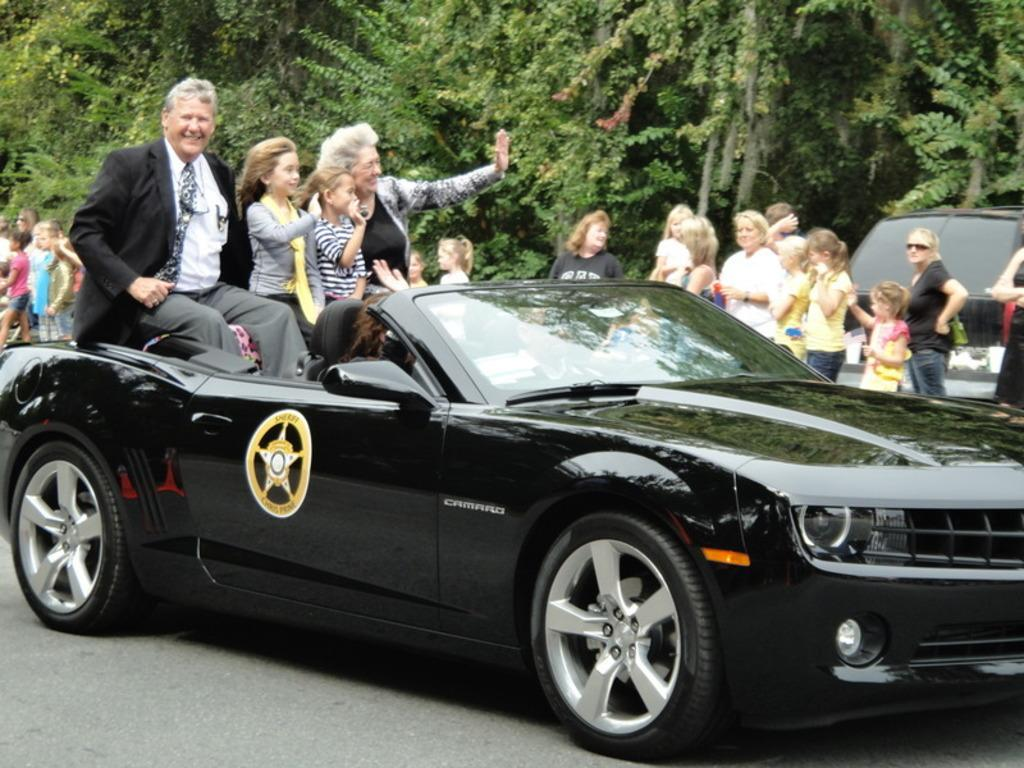What is the main subject of the image? The main subject of the image is a car. Who or what can be seen inside the car? There are people inside the car. Can you describe the surroundings of the car? There are more people visible in the background, at least one other vehicle, and trees present in the image. How are the people in the image feeling or expressing themselves? Some people in the image are smiling. What type of ornament is hanging from the rearview mirror in the image? There is no ornament hanging from the rearview mirror in the image. What route are the people in the car planning to take? The provided facts do not mention any information about the route the people in the car are planning to take. 